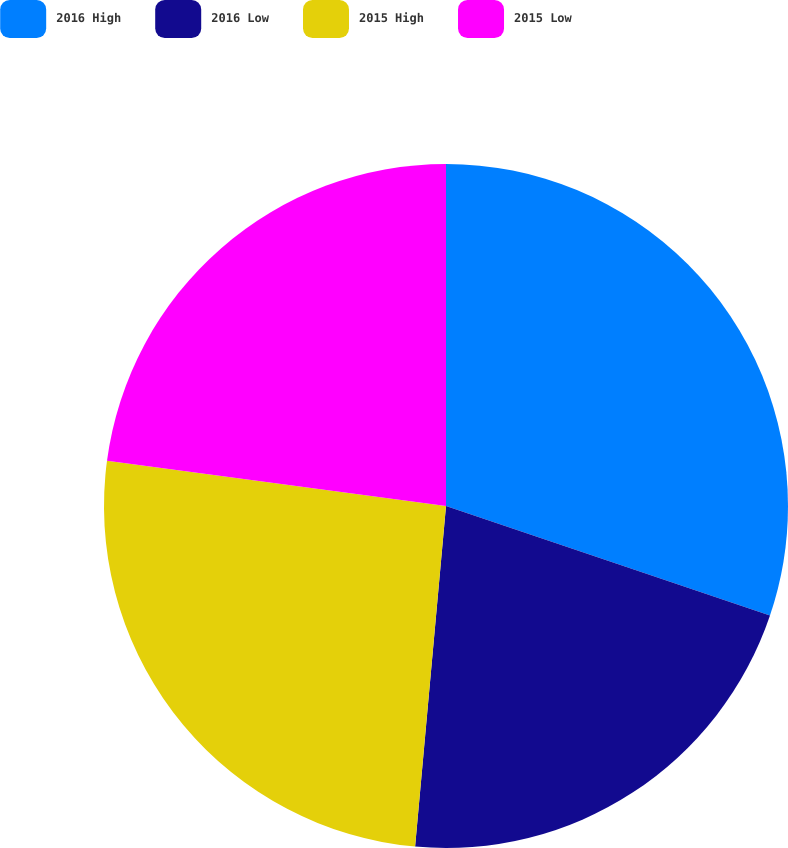Convert chart. <chart><loc_0><loc_0><loc_500><loc_500><pie_chart><fcel>2016 High<fcel>2016 Low<fcel>2015 High<fcel>2015 Low<nl><fcel>30.19%<fcel>21.25%<fcel>25.67%<fcel>22.89%<nl></chart> 